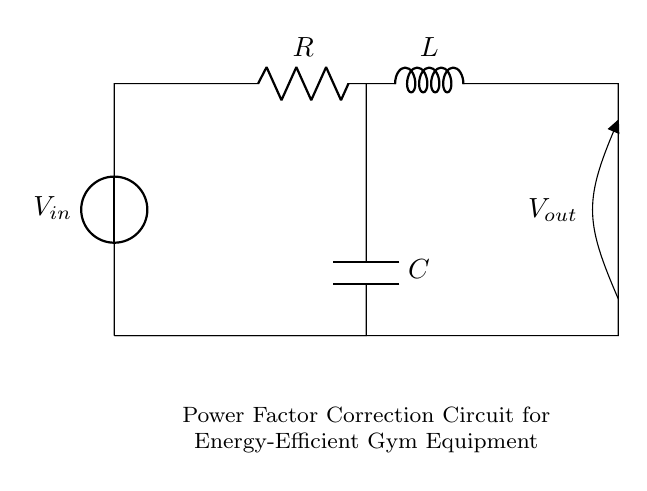What type of components are in this circuit? The circuit consists of a resistor, an inductor, and a capacitor, which are used for power factor correction.
Answer: Resistor, Inductor, Capacitor What is the purpose of the capacitor in this circuit? The capacitor helps in correcting the power factor by offsetting the inductive reactance of the inductor, thereby improving the overall efficiency of the circuit.
Answer: Power factor correction How are the components connected in this circuit? The resistor, inductor, and capacitor are arranged in a series configuration with the voltage source, allowing current to flow through each component sequentially.
Answer: Series configuration What is the input voltage denoted in the circuit? The input voltage is indicated by the source labeled "Vin" in the circuit diagram, showing the electrical supply to the components.
Answer: Vin How does the inductor affect energy efficiency in this circuit? The inductor introduces inductive reactance, which can lead to a lower power factor; thus, the capacitor works to counteract this effect, enhancing energy efficiency.
Answer: Lowers power factor What is the output voltage represented in this circuit? The output voltage is labeled "Vout" and indicates the voltage across the load or the output terminal of the circuit after the components.
Answer: Vout 